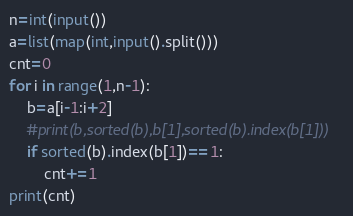Convert code to text. <code><loc_0><loc_0><loc_500><loc_500><_Python_>n=int(input())
a=list(map(int,input().split()))
cnt=0
for i in range(1,n-1):
    b=a[i-1:i+2]
    #print(b,sorted(b),b[1],sorted(b).index(b[1]))
    if sorted(b).index(b[1])==1:
        cnt+=1
print(cnt)
</code> 